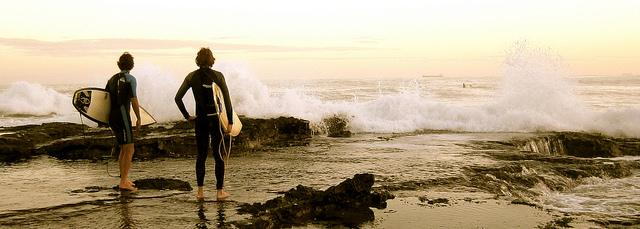Why are the surfer's hesitant to surf here? rocks 